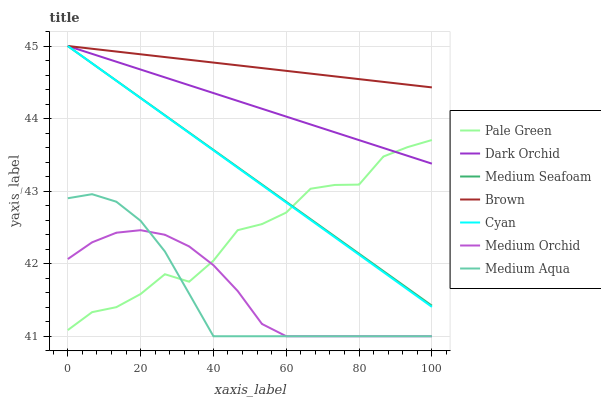Does Medium Aqua have the minimum area under the curve?
Answer yes or no. Yes. Does Brown have the maximum area under the curve?
Answer yes or no. Yes. Does Medium Orchid have the minimum area under the curve?
Answer yes or no. No. Does Medium Orchid have the maximum area under the curve?
Answer yes or no. No. Is Cyan the smoothest?
Answer yes or no. Yes. Is Pale Green the roughest?
Answer yes or no. Yes. Is Medium Orchid the smoothest?
Answer yes or no. No. Is Medium Orchid the roughest?
Answer yes or no. No. Does Dark Orchid have the lowest value?
Answer yes or no. No. Does Medium Orchid have the highest value?
Answer yes or no. No. Is Medium Aqua less than Medium Seafoam?
Answer yes or no. Yes. Is Brown greater than Medium Orchid?
Answer yes or no. Yes. Does Medium Aqua intersect Medium Seafoam?
Answer yes or no. No. 